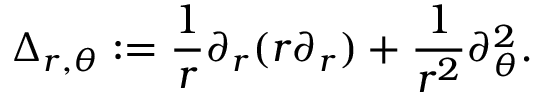<formula> <loc_0><loc_0><loc_500><loc_500>\Delta _ { r , \theta } \colon = \frac { 1 } { r } \partial _ { r } ( r \partial _ { r } ) + \frac { 1 } { r ^ { 2 } } \partial _ { \theta } ^ { 2 } .</formula> 